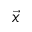Convert formula to latex. <formula><loc_0><loc_0><loc_500><loc_500>\vec { x }</formula> 